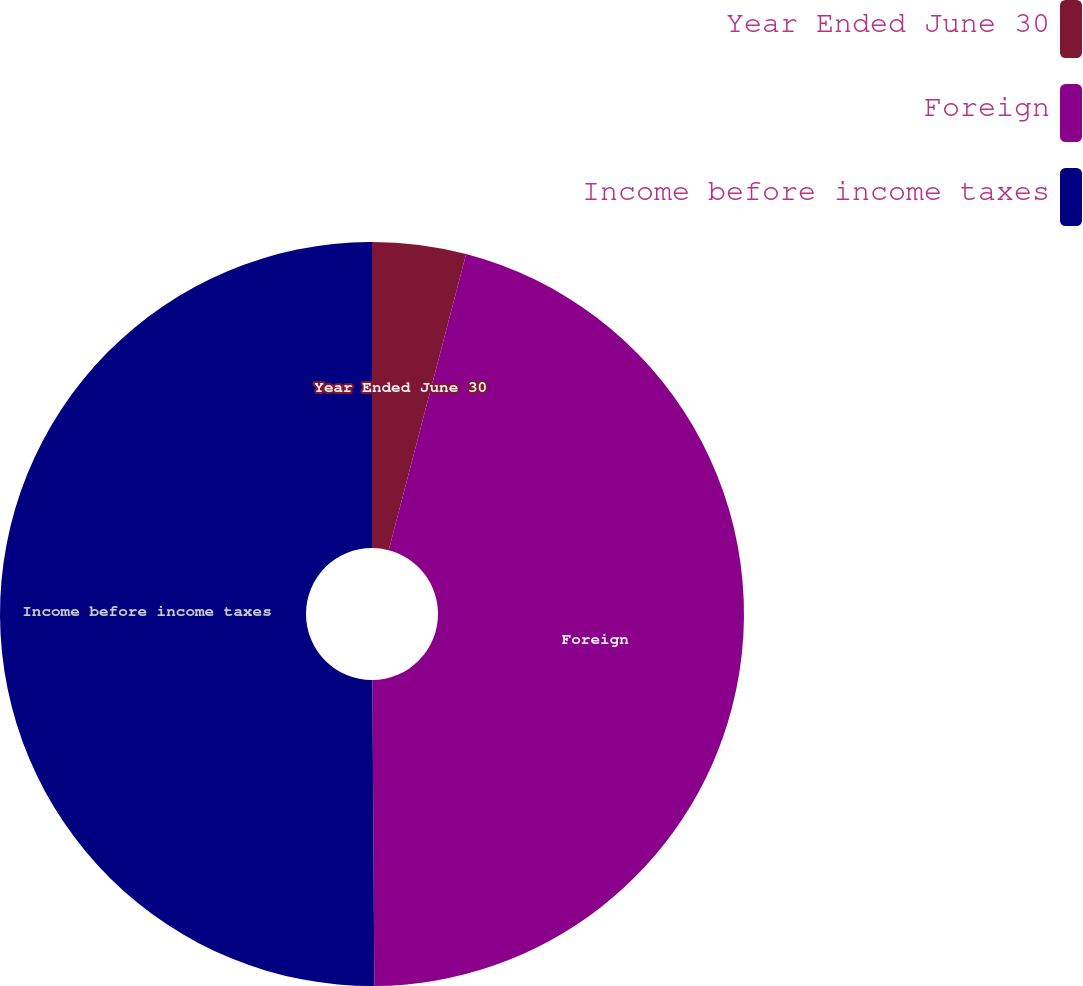Convert chart to OTSL. <chart><loc_0><loc_0><loc_500><loc_500><pie_chart><fcel>Year Ended June 30<fcel>Foreign<fcel>Income before income taxes<nl><fcel>4.07%<fcel>45.83%<fcel>50.1%<nl></chart> 